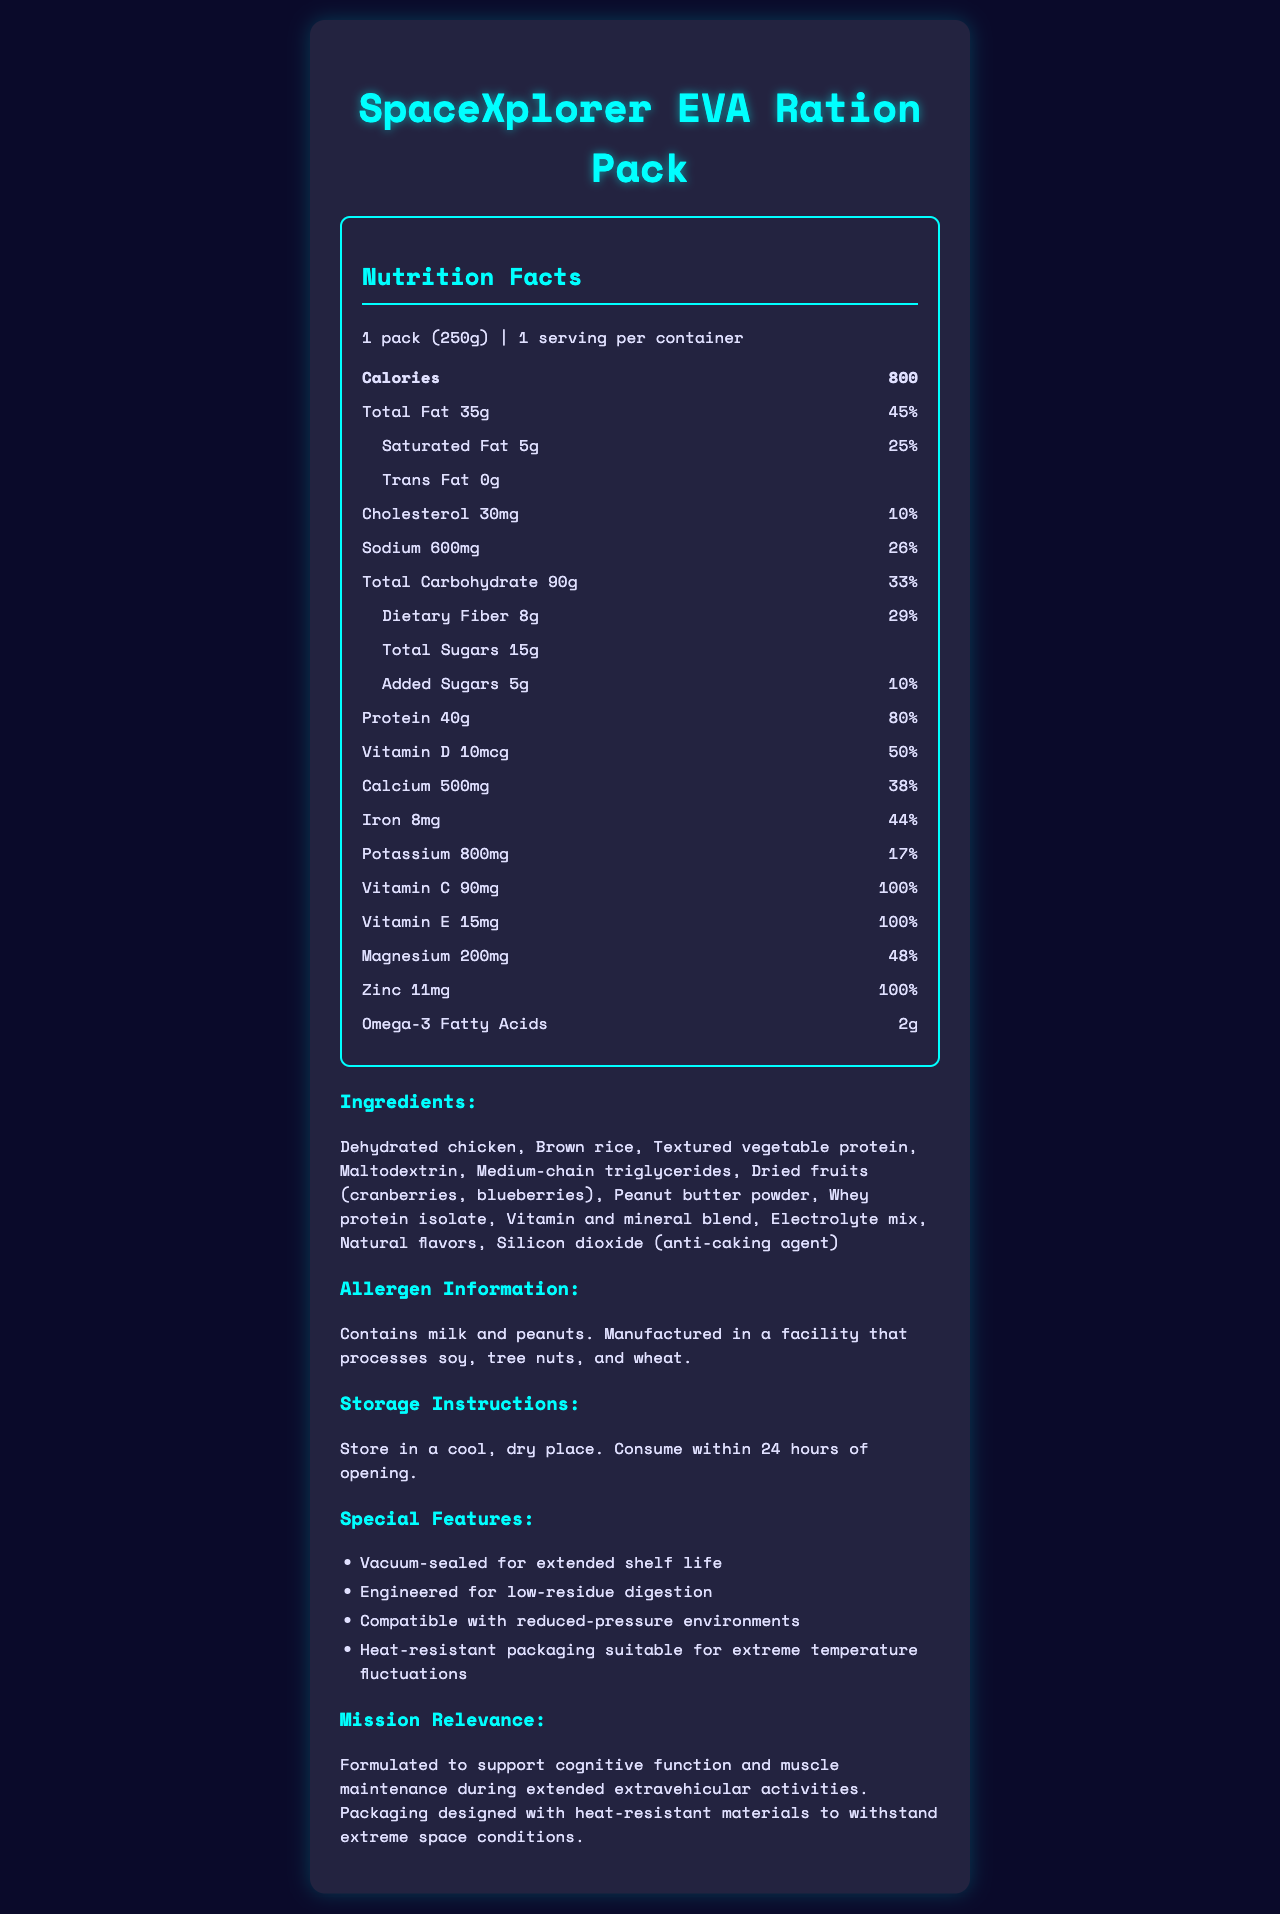what is the serving size for the SpaceXplorer EVA Ration Pack? The serving size is explicitly mentioned as 1 pack (250g) in the nutrition facts.
Answer: 1 pack (250g) how many servings are in one container? The document states there is 1 serving per container.
Answer: 1 what is the total fat content per serving? The total fat content per serving is listed as 35g.
Answer: 35g how much protein is in one serving? The protein content is 40g per serving.
Answer: 40g what percentage of the daily value is the dietary fiber in one serving? The daily value percentage for dietary fiber is listed as 29%.
Answer: 29% which allergens are present in the SpaceXplorer EVA Ration Pack? The allergen information specifically states that the product contains milk and peanuts.
Answer: Contains milk and peanuts what are the storage instructions for this ration pack? The storage instructions advise storing in a cool, dry place and consuming within 24 hours of opening.
Answer: Store in a cool, dry place. Consume within 24 hours of opening. how many grams of total sugars are in one serving? A. 5g B. 8g C. 10g D. 15g The document states there are 15g of total sugars in one serving.
Answer: D. 15g what is the percent daily value of calcium per serving? A. 17% B. 38% C. 44% D. 50% The percent daily value of calcium per serving is listed as 38%.
Answer: B. 38% does the product contain any trans fat? The document explicitly states that the trans fat content is 0g.
Answer: No Summarize the main features and nutritional benefits of the SpaceXplorer EVA Ration Pack. This summary captures the key nutritional details, packaging, and the specific design features tailored for space exploration.
Answer: The SpaceXplorer EVA Ration Pack is a calorie-dense, vacuum-sealed food designed for space extravehicular activities. It contains 800 calories per pack with significant protein (40g) and essential vitamins and minerals to support cognitive function and muscle maintenance. It's engineered for low-residue digestion and is compatible with reduced-pressure environments. The packaging is heat-resistant to withstand extreme space conditions. what is the main source of omega-3 fatty acids in the ration pack? The source of omega-3 fatty acids is not specified in the ingredient list or the nutritional facts provided.
Answer: Not enough information how is the packaging of the SpaceXplorer EVA Ration Pack designed to withstand space conditions? The document mentions that the packaging is heat-resistant and suitable for extreme temperature fluctuations.
Answer: Heat-resistant packaging suitable for extreme temperature fluctuations 